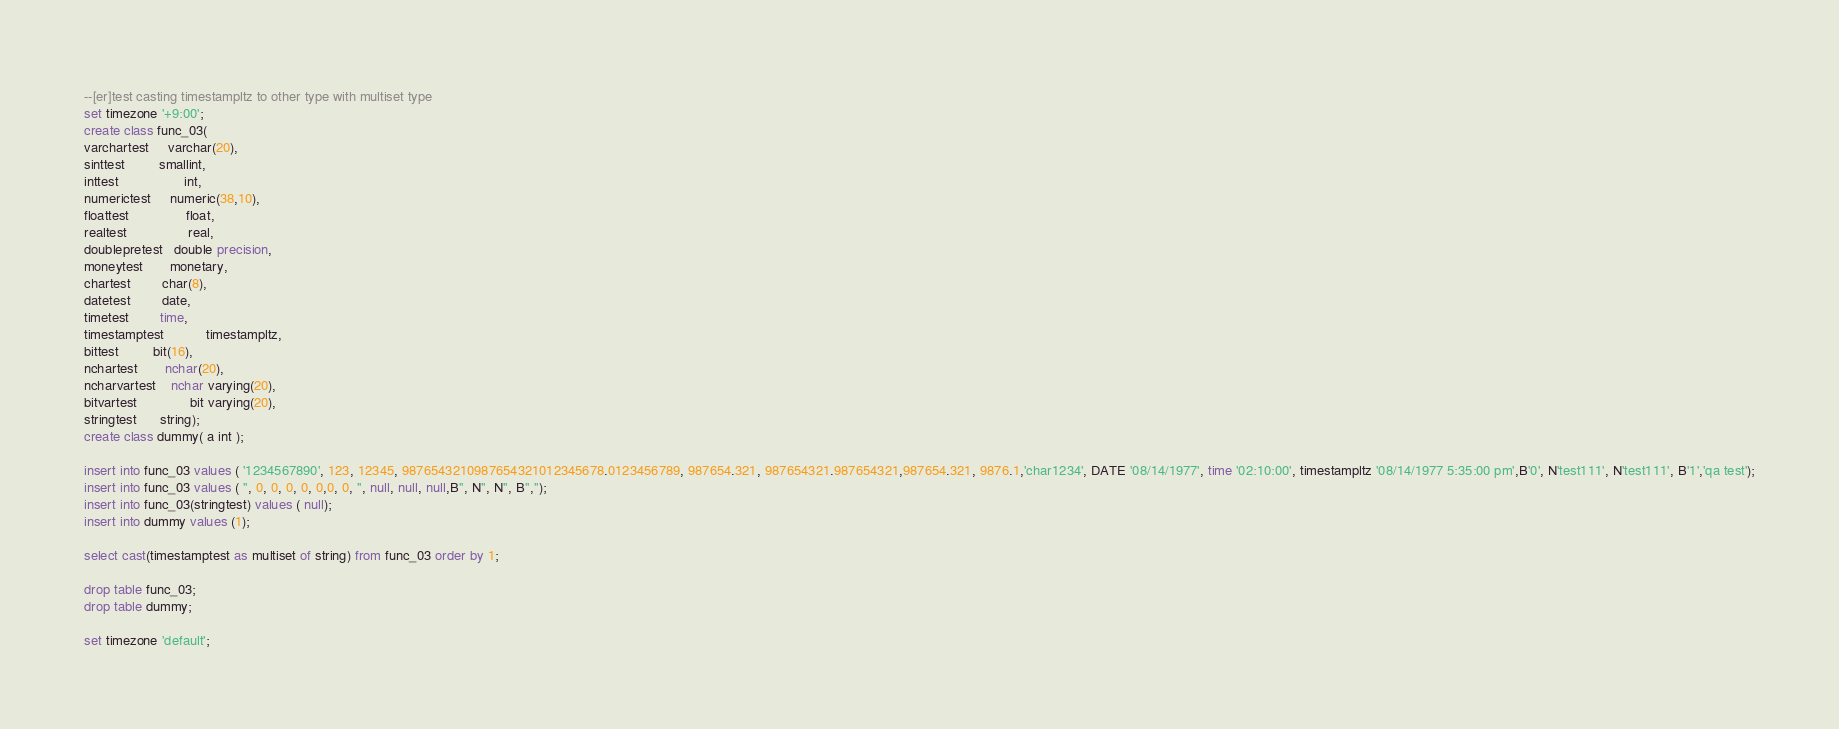Convert code to text. <code><loc_0><loc_0><loc_500><loc_500><_SQL_>--[er]test casting timestampltz to other type with multiset type
set timezone '+9:00';
create class func_03(
varchartest     varchar(20),
sinttest         smallint,
inttest                 int,
numerictest     numeric(38,10),
floattest               float,
realtest                real,
doublepretest   double precision,
moneytest       monetary,
chartest        char(8),
datetest        date,
timetest        time,
timestamptest           timestampltz,
bittest         bit(16),
nchartest       nchar(20),
ncharvartest    nchar varying(20),
bitvartest              bit varying(20),
stringtest      string);
create class dummy( a int );

insert into func_03 values ( '1234567890', 123, 12345, 9876543210987654321012345678.0123456789, 987654.321, 987654321.987654321,987654.321, 9876.1,'char1234', DATE '08/14/1977', time '02:10:00', timestampltz '08/14/1977 5:35:00 pm',B'0', N'test111', N'test111', B'1','qa test');
insert into func_03 values ( '', 0, 0, 0, 0, 0,0, 0, '', null, null, null,B'', N'', N'', B'','');
insert into func_03(stringtest) values ( null);
insert into dummy values (1);

select cast(timestamptest as multiset of string) from func_03 order by 1;

drop table func_03;
drop table dummy;

set timezone 'default';
</code> 